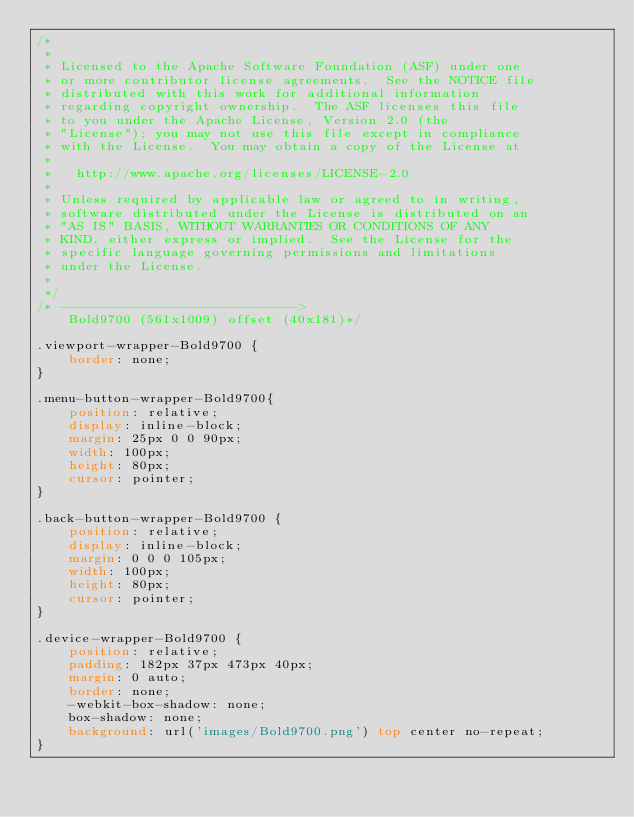Convert code to text. <code><loc_0><loc_0><loc_500><loc_500><_CSS_>/*
 *
 * Licensed to the Apache Software Foundation (ASF) under one
 * or more contributor license agreements.  See the NOTICE file
 * distributed with this work for additional information
 * regarding copyright ownership.  The ASF licenses this file
 * to you under the Apache License, Version 2.0 (the
 * "License"); you may not use this file except in compliance
 * with the License.  You may obtain a copy of the License at
 *
 *   http://www.apache.org/licenses/LICENSE-2.0
 *
 * Unless required by applicable law or agreed to in writing,
 * software distributed under the License is distributed on an
 * "AS IS" BASIS, WITHOUT WARRANTIES OR CONDITIONS OF ANY
 * KIND, either express or implied.  See the License for the
 * specific language governing permissions and limitations
 * under the License.
 *
 */
/* ------------------------------>
    Bold9700 (561x1009) offset (40x181)*/

.viewport-wrapper-Bold9700 {
    border: none;
}

.menu-button-wrapper-Bold9700{
    position: relative;
    display: inline-block;
    margin: 25px 0 0 90px;
    width: 100px;
    height: 80px;
    cursor: pointer;
}

.back-button-wrapper-Bold9700 {
    position: relative;
    display: inline-block;
    margin: 0 0 0 105px;
    width: 100px;
    height: 80px;
    cursor: pointer;
}

.device-wrapper-Bold9700 {
    position: relative;
    padding: 182px 37px 473px 40px;
    margin: 0 auto;
    border: none;
    -webkit-box-shadow: none;
    box-shadow: none;
    background: url('images/Bold9700.png') top center no-repeat;
}
</code> 